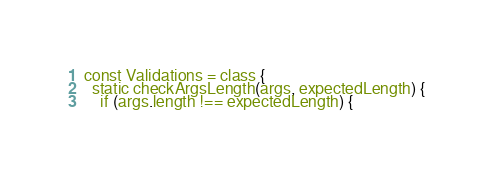<code> <loc_0><loc_0><loc_500><loc_500><_JavaScript_>const Validations = class {
  static checkArgsLength(args, expectedLength) {
    if (args.length !== expectedLength) {</code> 